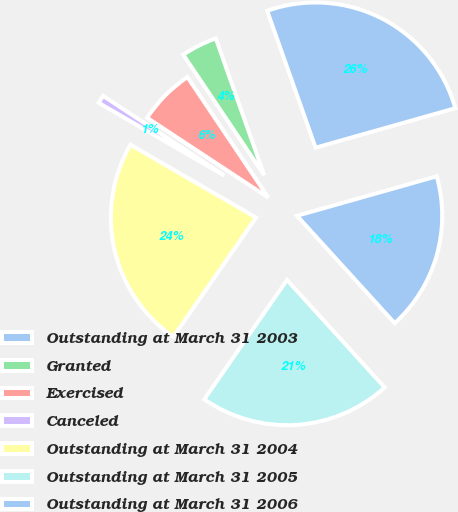Convert chart to OTSL. <chart><loc_0><loc_0><loc_500><loc_500><pie_chart><fcel>Outstanding at March 31 2003<fcel>Granted<fcel>Exercised<fcel>Canceled<fcel>Outstanding at March 31 2004<fcel>Outstanding at March 31 2005<fcel>Outstanding at March 31 2006<nl><fcel>26.03%<fcel>4.0%<fcel>6.32%<fcel>0.91%<fcel>23.71%<fcel>21.39%<fcel>17.64%<nl></chart> 